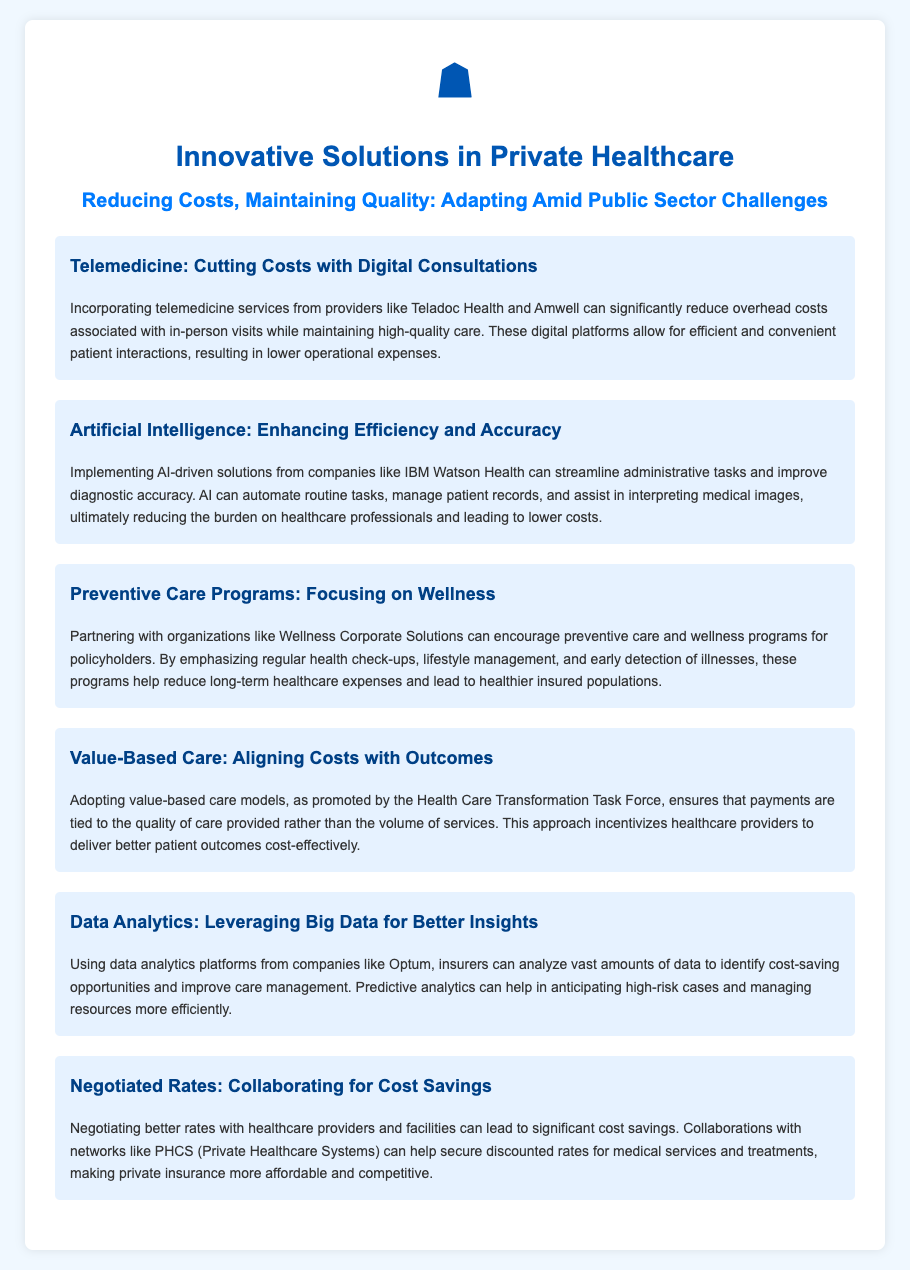What is the first innovative solution mentioned? The first solution discussed in the document is telemedicine, which emphasizes digital consultations.
Answer: Telemedicine What company is associated with telemedicine services? The document highlights Teladoc Health and Amwell as providers of telemedicine services.
Answer: Teladoc Health and Amwell What technology is mentioned for enhancing efficiency? The document mentions AI-driven solutions from IBM Watson Health for improving efficiency and accuracy.
Answer: IBM Watson Health What type of care does the document suggest focusing on? The document suggests focusing on preventive care programs to encourage regular health check-ups and lifestyle management.
Answer: Preventive care programs What is the goal of adopting value-based care models? The goal outlined in the document is to tie payments to the quality of care provided rather than the volume of services.
Answer: Quality of care Which company’s analytics platform is referenced for better insights? The document refers to data analytics platforms from Optum for analyzing vast amounts of data.
Answer: Optum What result do preventive care programs aim to achieve? The preventive care programs aim to lead to healthier insured populations and reduce long-term healthcare expenses.
Answer: Healthier insured populations Which collaboration is suggested for negotiating better rates? The document suggests collaborating with networks like PHCS for securing discounted medical services.
Answer: PHCS What is the main theme of the flyer? The main theme is about reducing costs in private healthcare while maintaining quality amid challenges in the public sector.
Answer: Reducing costs, maintaining quality 